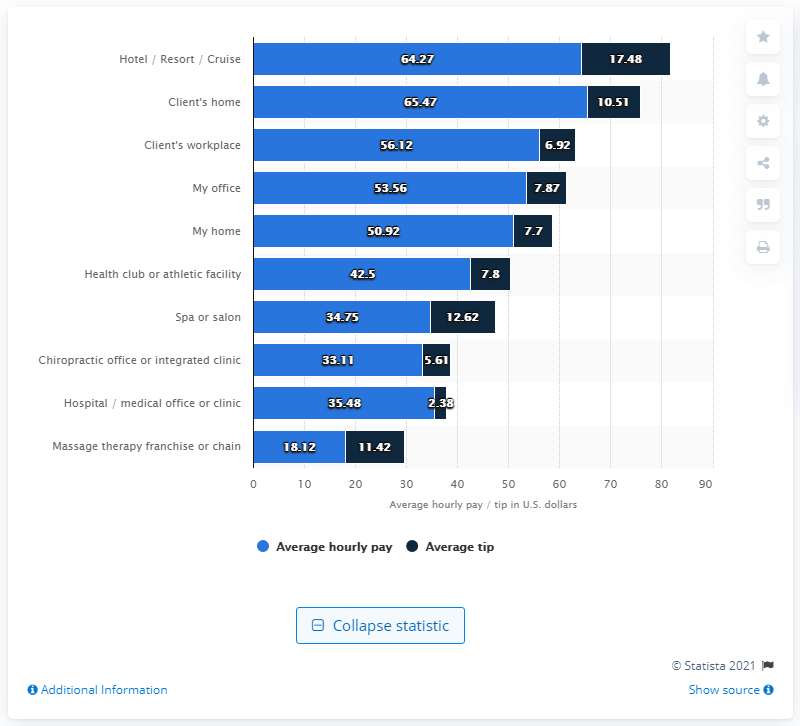List a handful of essential elements in this visual. According to data collected in 2012, the average tip for a massage therapist was 10.51. The average hourly wage for massage therapists who worked from home was $65.47. 